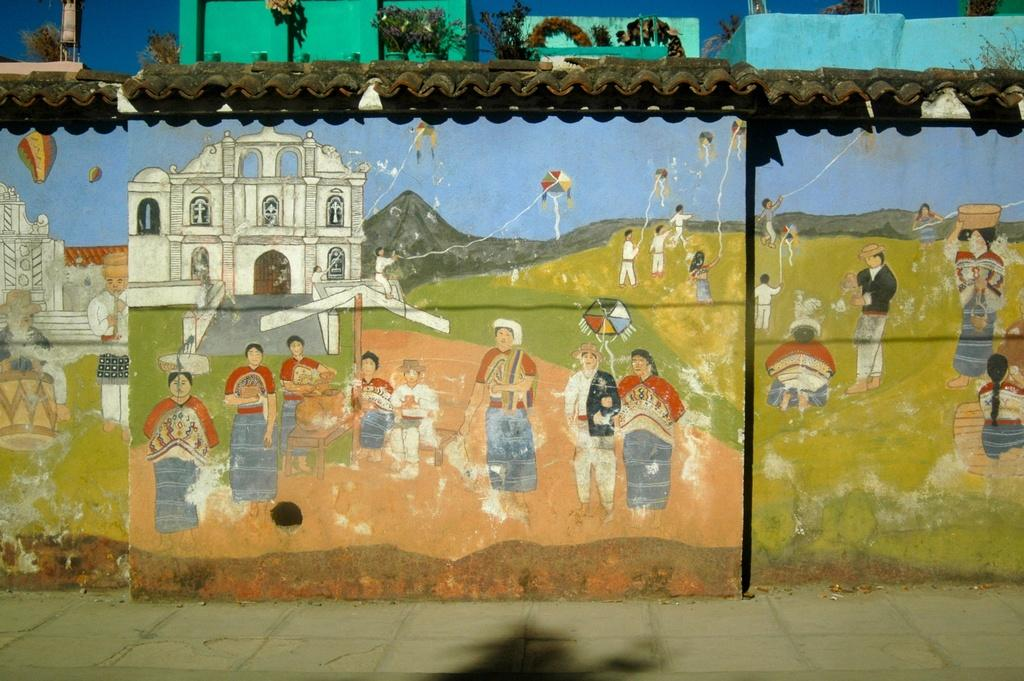What type of art is depicted in the image? The image contains art of some persons, a building, and mountains. Are there any objects on the wall in the image? Yes, there are kites on the wall in the image. What can be seen on the roof in the image? There are flower pots on the roof in the image. What is visible in the background of the image? The sky is visible in the image. What type of toys can be seen playing with the kites in the image? There are no toys present in the image; it only features art of persons, a building, and mountains, as well as kites on the wall and flower pots on the roof. 